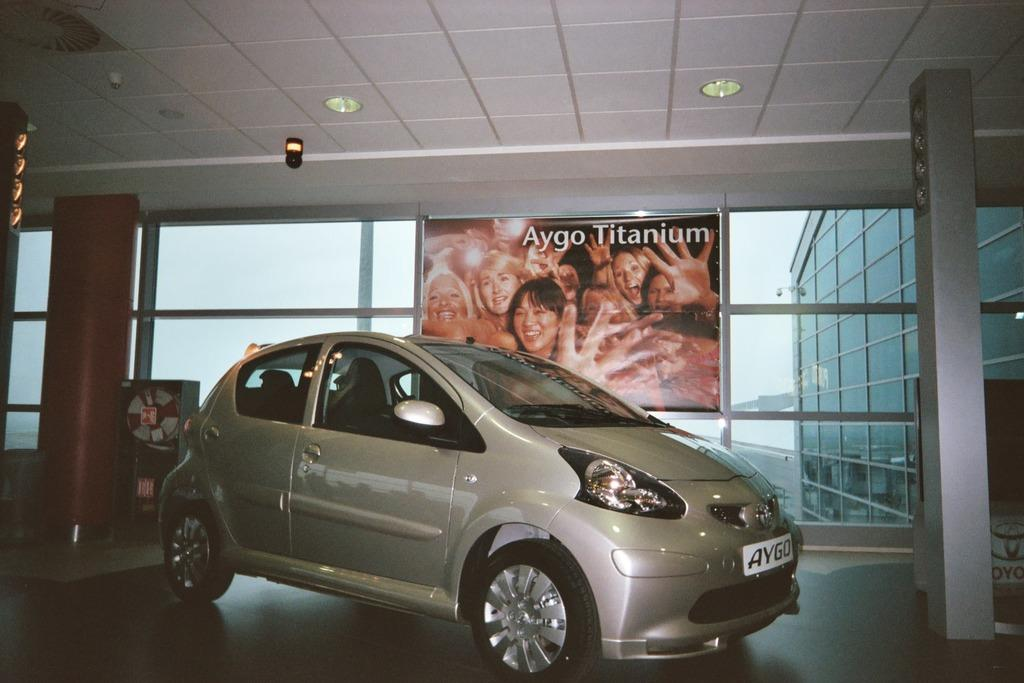What is the main subject of the image? There is a car in the image. What is located beside the car? There is a poster on the glass beside the car. What can be seen in the image that provides illumination? There are lights visible in the image. What is visible in the background of the image? There is a building in the background of the image. What type of letter is being written by the zebra in the image? There is no zebra or letter present in the image. 